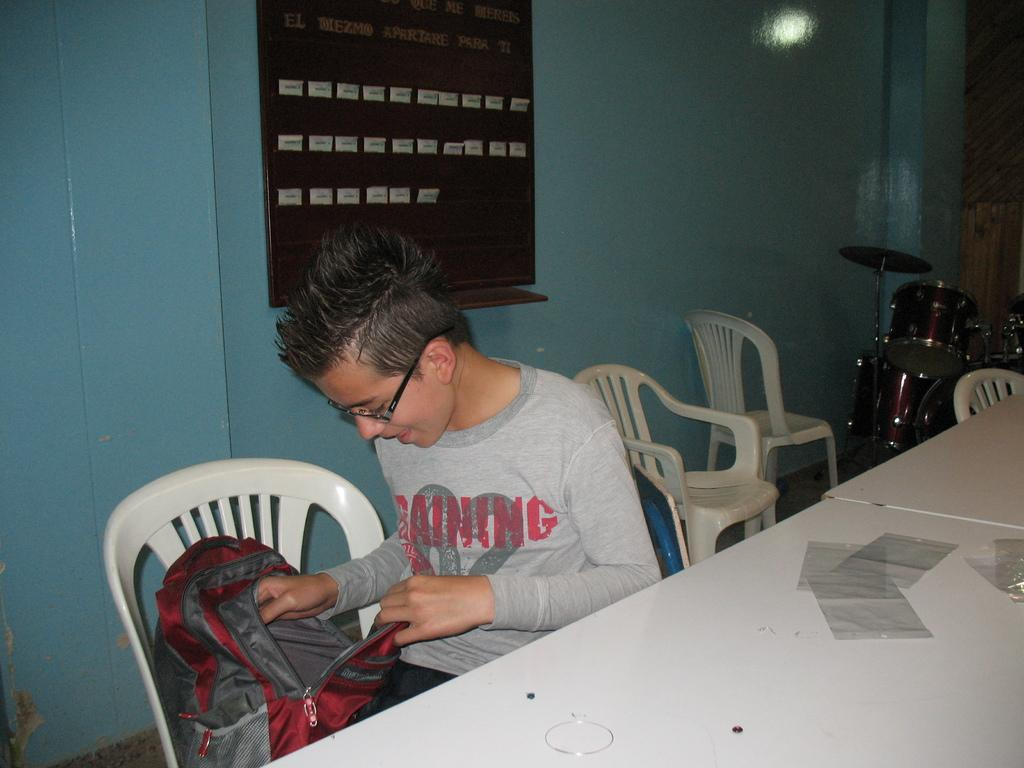What is the kid doing in the image? The kid is sitting in a chair. What is the kid looking at? The kid is looking at a red backpack. What is in front of the kid? There is a table in front of the kid. What can be seen in the background of the image? There are drums in the background of the image. What type of scarf is the goat wearing in the image? There is no goat or scarf present in the image. What is the kid's relationship to the person in the image? The provided facts do not mention any other person in the image, so we cannot determine the kid's relationship to anyone else. 